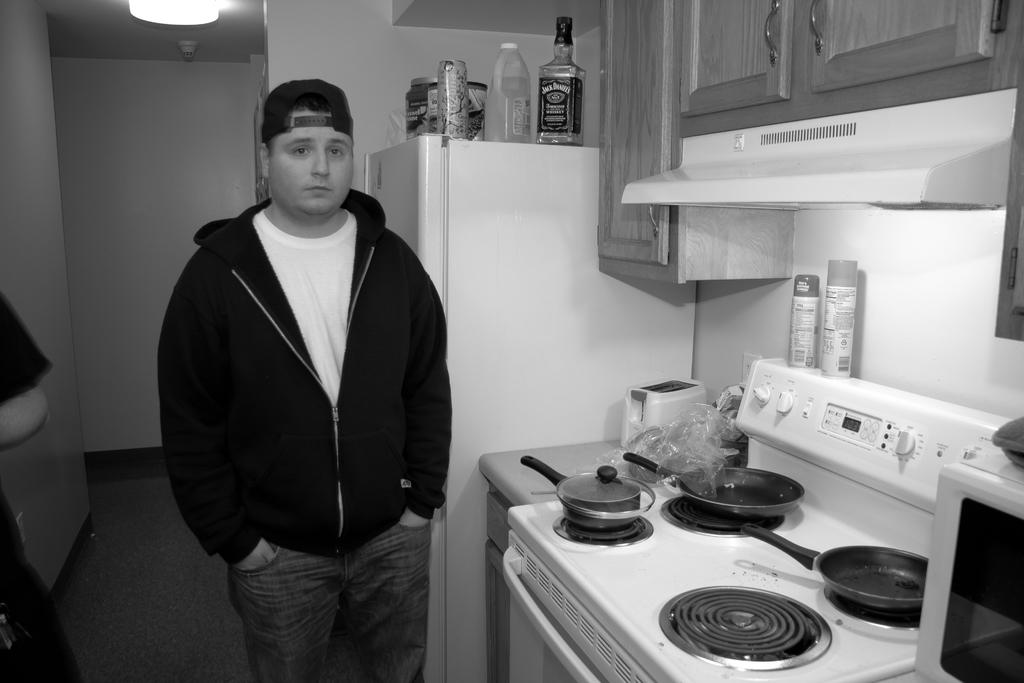<image>
Relay a brief, clear account of the picture shown. A man stands next to a fridge with a bottle of Jack Daniels on top of it. 